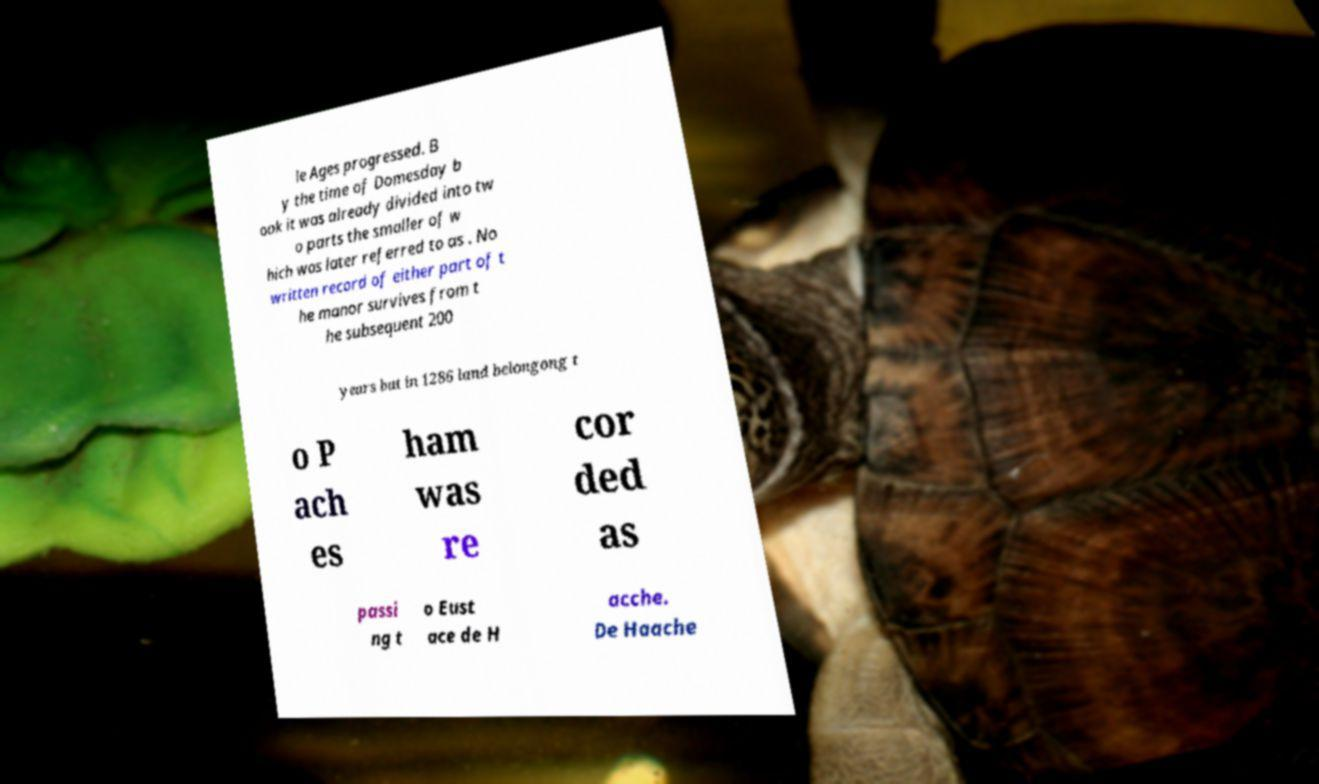There's text embedded in this image that I need extracted. Can you transcribe it verbatim? le Ages progressed. B y the time of Domesday b ook it was already divided into tw o parts the smaller of w hich was later referred to as . No written record of either part of t he manor survives from t he subsequent 200 years but in 1286 land belongong t o P ach es ham was re cor ded as passi ng t o Eust ace de H acche. De Haache 